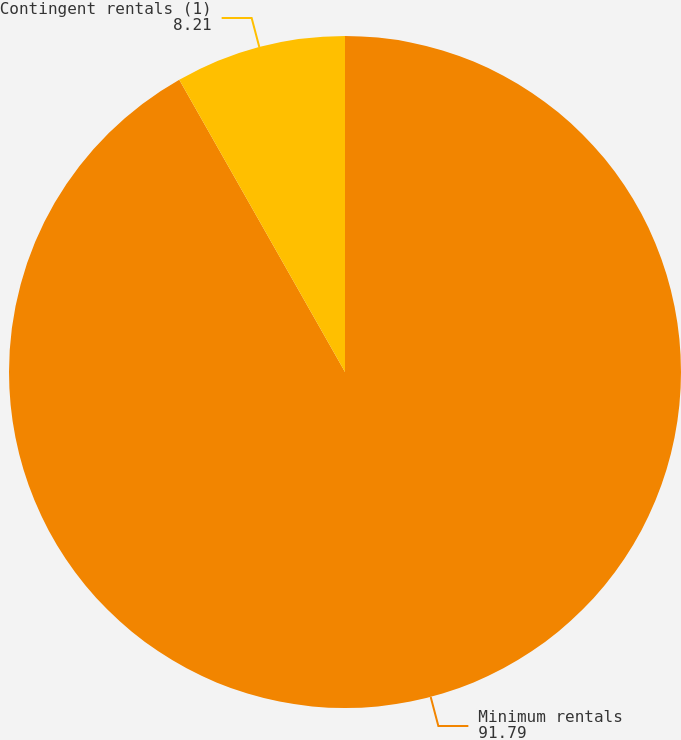<chart> <loc_0><loc_0><loc_500><loc_500><pie_chart><fcel>Minimum rentals<fcel>Contingent rentals (1)<nl><fcel>91.79%<fcel>8.21%<nl></chart> 